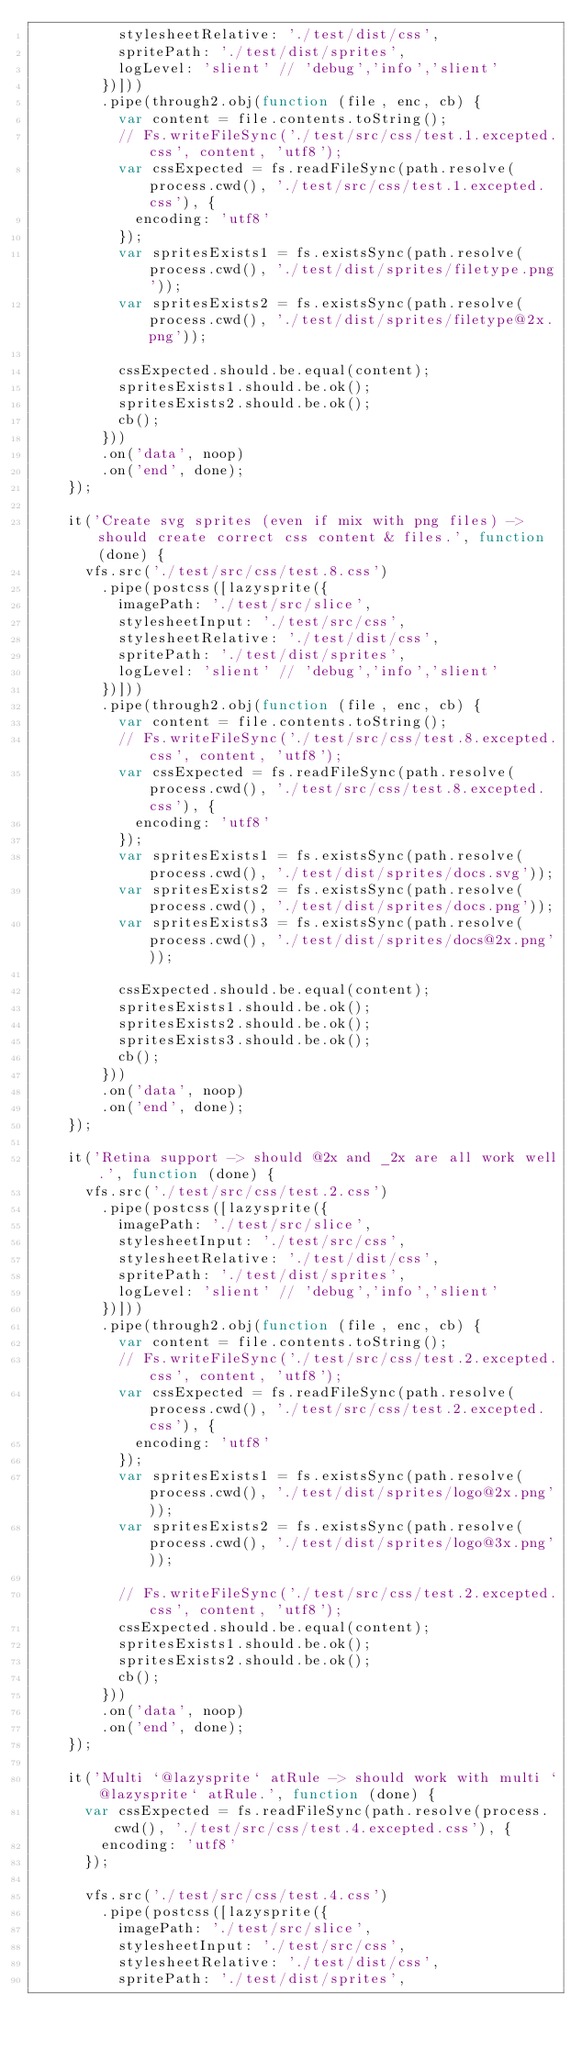Convert code to text. <code><loc_0><loc_0><loc_500><loc_500><_JavaScript_>          stylesheetRelative: './test/dist/css',
          spritePath: './test/dist/sprites',
          logLevel: 'slient' // 'debug','info','slient'
        })]))
        .pipe(through2.obj(function (file, enc, cb) {
          var content = file.contents.toString();
          // Fs.writeFileSync('./test/src/css/test.1.excepted.css', content, 'utf8');
          var cssExpected = fs.readFileSync(path.resolve(process.cwd(), './test/src/css/test.1.excepted.css'), {
            encoding: 'utf8'
          });
          var spritesExists1 = fs.existsSync(path.resolve(process.cwd(), './test/dist/sprites/filetype.png'));
          var spritesExists2 = fs.existsSync(path.resolve(process.cwd(), './test/dist/sprites/filetype@2x.png'));

          cssExpected.should.be.equal(content);
          spritesExists1.should.be.ok();
          spritesExists2.should.be.ok();
          cb();
        }))
        .on('data', noop)
        .on('end', done);
    });

    it('Create svg sprites (even if mix with png files) -> should create correct css content & files.', function (done) {
      vfs.src('./test/src/css/test.8.css')
        .pipe(postcss([lazysprite({
          imagePath: './test/src/slice',
          stylesheetInput: './test/src/css',
          stylesheetRelative: './test/dist/css',
          spritePath: './test/dist/sprites',
          logLevel: 'slient' // 'debug','info','slient'
        })]))
        .pipe(through2.obj(function (file, enc, cb) {
          var content = file.contents.toString();
          // Fs.writeFileSync('./test/src/css/test.8.excepted.css', content, 'utf8');
          var cssExpected = fs.readFileSync(path.resolve(process.cwd(), './test/src/css/test.8.excepted.css'), {
            encoding: 'utf8'
          });
          var spritesExists1 = fs.existsSync(path.resolve(process.cwd(), './test/dist/sprites/docs.svg'));
          var spritesExists2 = fs.existsSync(path.resolve(process.cwd(), './test/dist/sprites/docs.png'));
          var spritesExists3 = fs.existsSync(path.resolve(process.cwd(), './test/dist/sprites/docs@2x.png'));

          cssExpected.should.be.equal(content);
          spritesExists1.should.be.ok();
          spritesExists2.should.be.ok();
          spritesExists3.should.be.ok();
          cb();
        }))
        .on('data', noop)
        .on('end', done);
    });

    it('Retina support -> should @2x and _2x are all work well.', function (done) {
      vfs.src('./test/src/css/test.2.css')
        .pipe(postcss([lazysprite({
          imagePath: './test/src/slice',
          stylesheetInput: './test/src/css',
          stylesheetRelative: './test/dist/css',
          spritePath: './test/dist/sprites',
          logLevel: 'slient' // 'debug','info','slient'
        })]))
        .pipe(through2.obj(function (file, enc, cb) {
          var content = file.contents.toString();
          // Fs.writeFileSync('./test/src/css/test.2.excepted.css', content, 'utf8');
          var cssExpected = fs.readFileSync(path.resolve(process.cwd(), './test/src/css/test.2.excepted.css'), {
            encoding: 'utf8'
          });
          var spritesExists1 = fs.existsSync(path.resolve(process.cwd(), './test/dist/sprites/logo@2x.png'));
          var spritesExists2 = fs.existsSync(path.resolve(process.cwd(), './test/dist/sprites/logo@3x.png'));

          // Fs.writeFileSync('./test/src/css/test.2.excepted.css', content, 'utf8');
          cssExpected.should.be.equal(content);
          spritesExists1.should.be.ok();
          spritesExists2.should.be.ok();
          cb();
        }))
        .on('data', noop)
        .on('end', done);
    });

    it('Multi `@lazysprite` atRule -> should work with multi `@lazysprite` atRule.', function (done) {
      var cssExpected = fs.readFileSync(path.resolve(process.cwd(), './test/src/css/test.4.excepted.css'), {
        encoding: 'utf8'
      });

      vfs.src('./test/src/css/test.4.css')
        .pipe(postcss([lazysprite({
          imagePath: './test/src/slice',
          stylesheetInput: './test/src/css',
          stylesheetRelative: './test/dist/css',
          spritePath: './test/dist/sprites',</code> 